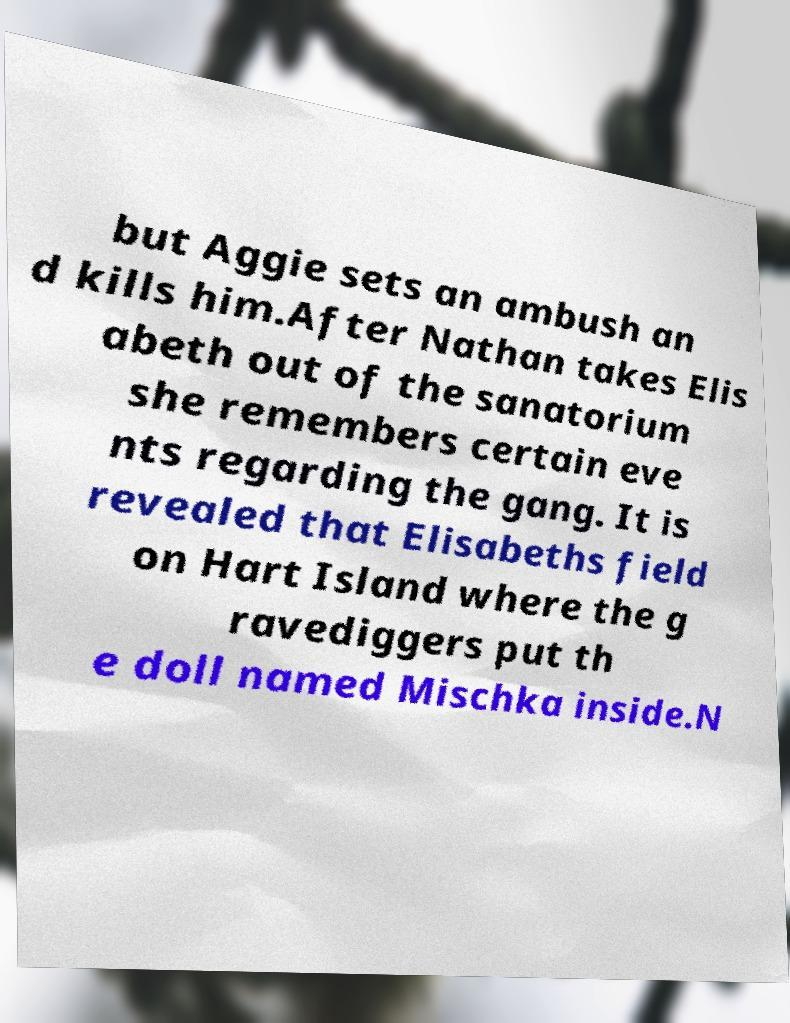I need the written content from this picture converted into text. Can you do that? but Aggie sets an ambush an d kills him.After Nathan takes Elis abeth out of the sanatorium she remembers certain eve nts regarding the gang. It is revealed that Elisabeths field on Hart Island where the g ravediggers put th e doll named Mischka inside.N 